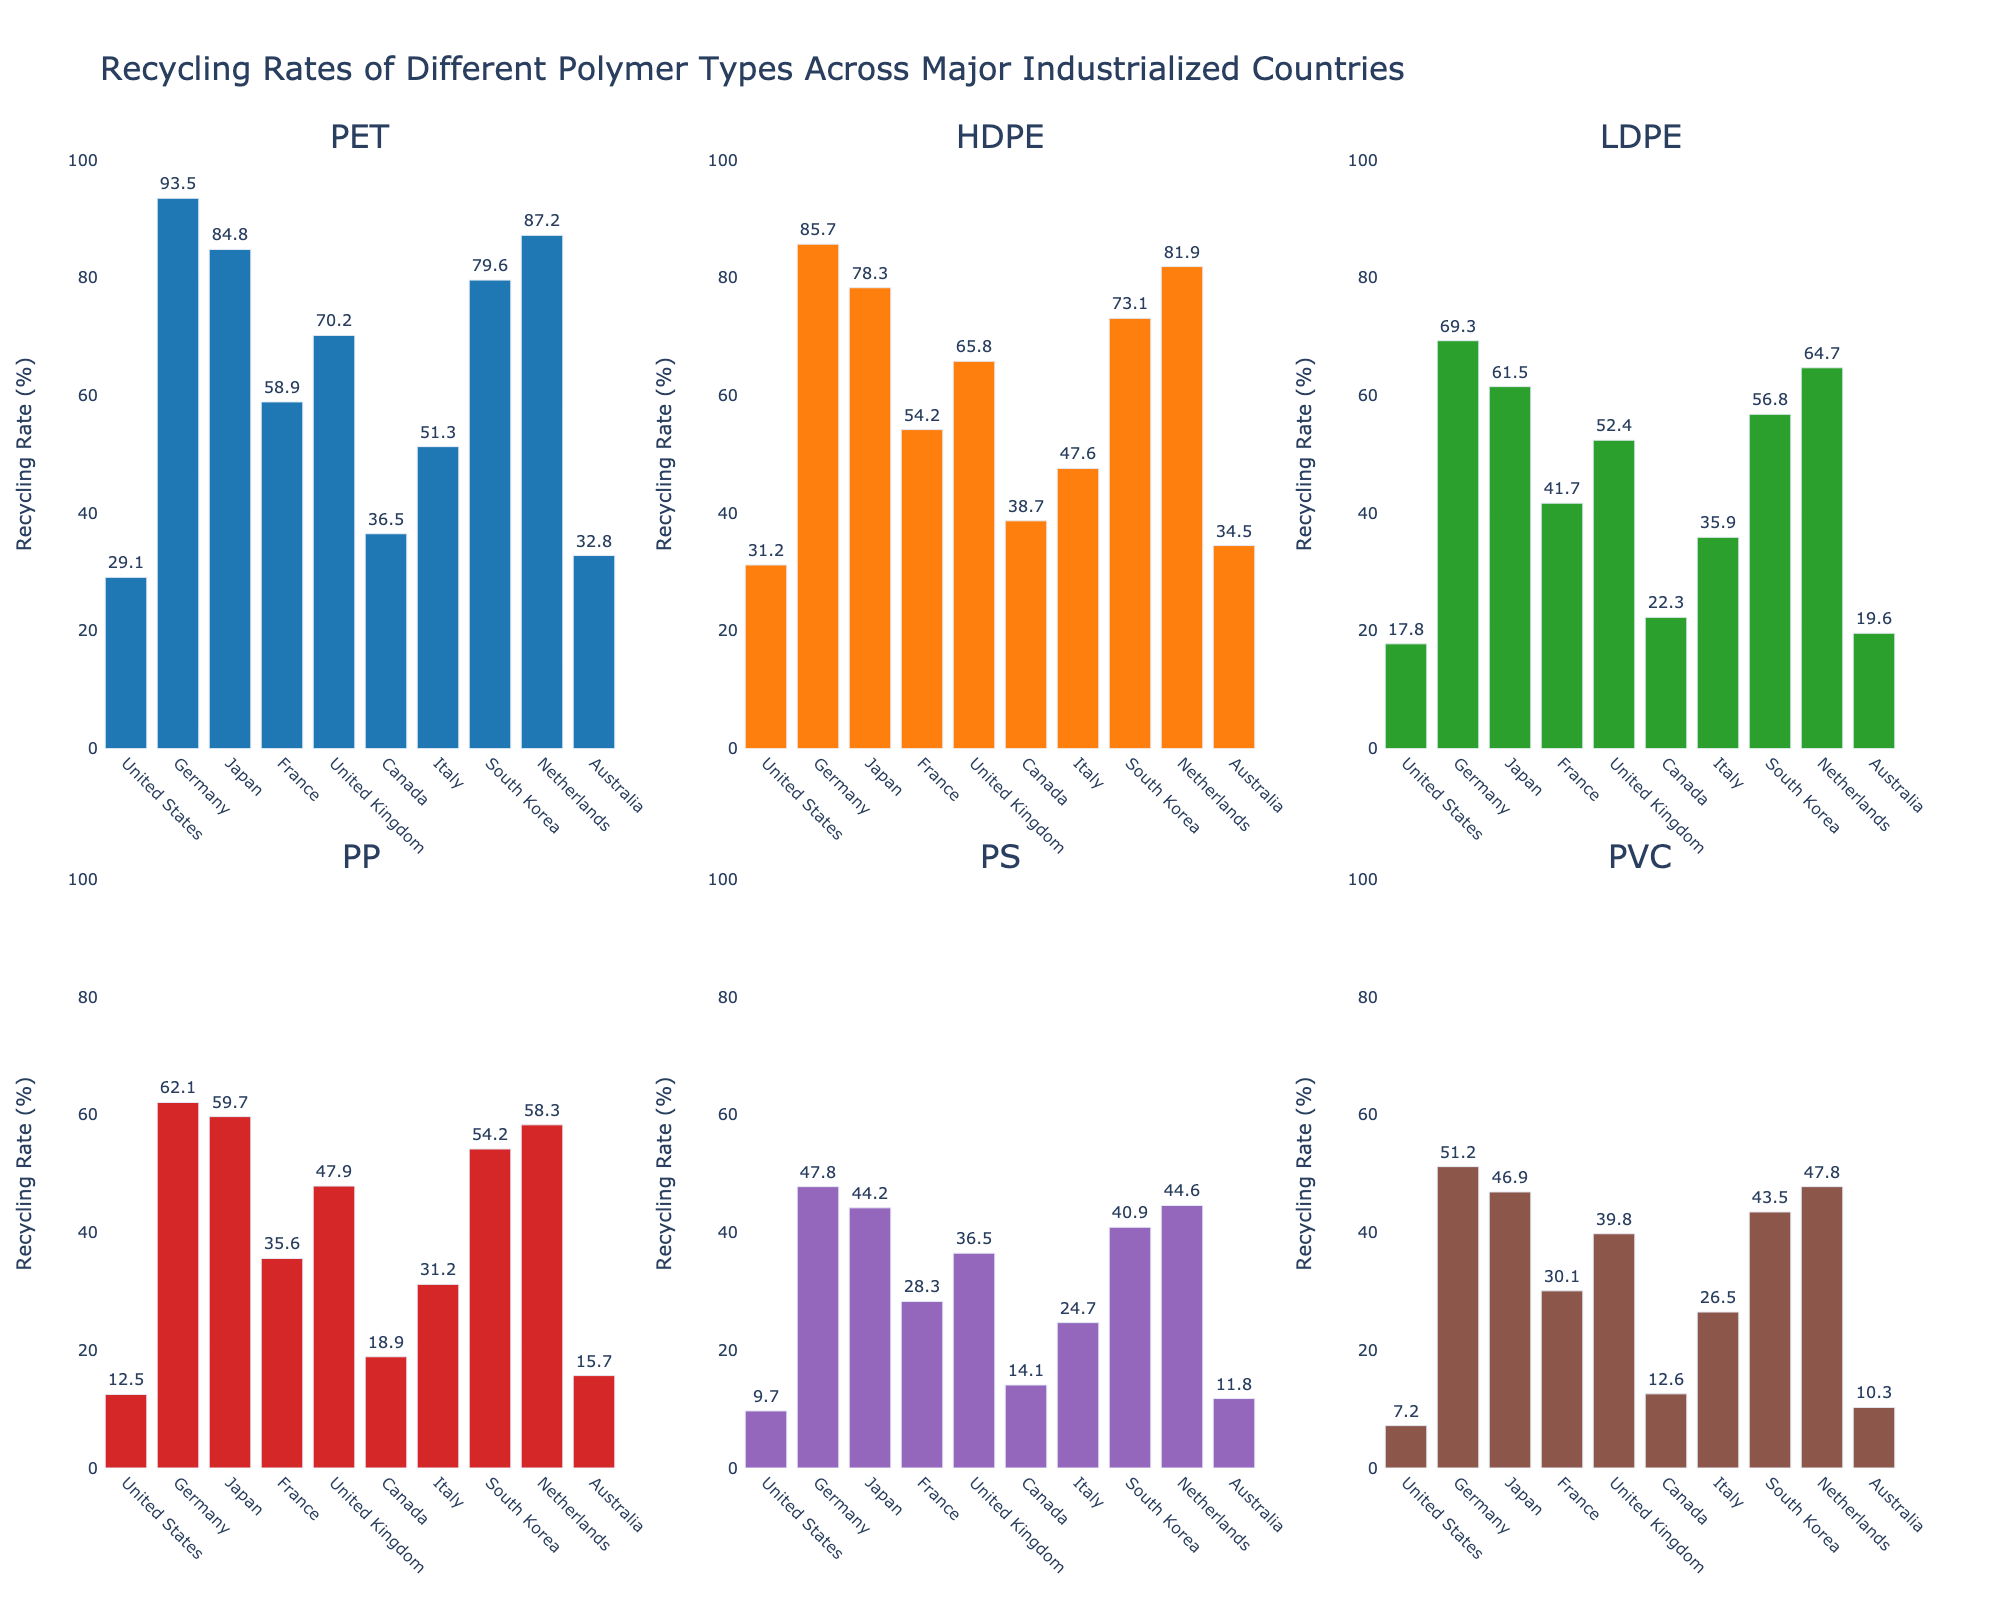Which country has the highest recycling rate for PET? The highest recycling rate for PET is indicated by the tallest bar in the PET subplot, and it's associated with the country "Germany."
Answer: Germany Which country has the lowest recycling rate for PVC? The smallest bar in the PVC subplot represents the country with the lowest recycling rate, which is "United States."
Answer: United States What is the average recycling rate for HDPE across all countries? To find the average, sum the recycling rates for HDPE in all countries and divide by the number of countries. (31.2 + 85.7 + 78.3 + 54.2 + 65.8 + 38.7 + 47.6 + 73.1 + 81.9 + 34.5) / 10 = 59.1%
Answer: 59.1% Which country has a higher recycling rate for LDPE than for PP? Compare the heights of the bars for LDPE and PP within each country subplot. Countries where the LDPE bar is higher than the PP bar include "United States," "Germany," "Japan," "France," "United Kingdom," "Canada," "Italy," "South Korea," "Netherlands," and "Australia." However, in this case, all LDPE rates are higher than PP rates universally.
Answer: All countries Which polymer type has the most significant recycling rate difference between Germany and the United States? Identify the difference in the height of the bars for each polymer between Germany and the United States and determine which has the largest difference. For example, PET: 93.5 - 29.1 = 64.4, HDPE: 85.7 - 31.2 = 54.5, LDPE: 69.3 - 17.8 = 51.5, PP: 62.1 - 12.5 = 49.6, PS: 47.8 - 9.7 = 38.1, PVC: 51.2 - 7.2 = 44. Germany and the United States show the most significant difference in recycling rates for PET (64.4).
Answer: PET In how many countries does the recycling rate for PS exceed 40%? Look at the PS subplot and count the bars that exceed 40%. They are "Germany," "Japan," "United Kingdom," "South Korea," and "Netherlands," making a total of 5.
Answer: 5 What is the combined recycling rate for PVC in Japan and South Korea? Add the recycling rates for PVC in Japan and South Korea: 46.9 (Japan) + 43.5 (South Korea) = 90.4.
Answer: 90.4% Which country has the closest recycling rates for PET and HDPE? Find the countries where the bars for PET and HDPE are nearest in height. "Japan" has PET at 84.8 and HDPE at 78.3, giving a difference of 6.5, which is the smallest difference among all countries.
Answer: Japan 